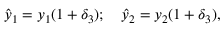<formula> <loc_0><loc_0><loc_500><loc_500>{ \hat { y } } _ { 1 } = y _ { 1 } ( 1 + \delta _ { 3 } ) ; \quad \hat { y } _ { 2 } = y _ { 2 } ( 1 + \delta _ { 3 } ) ,</formula> 